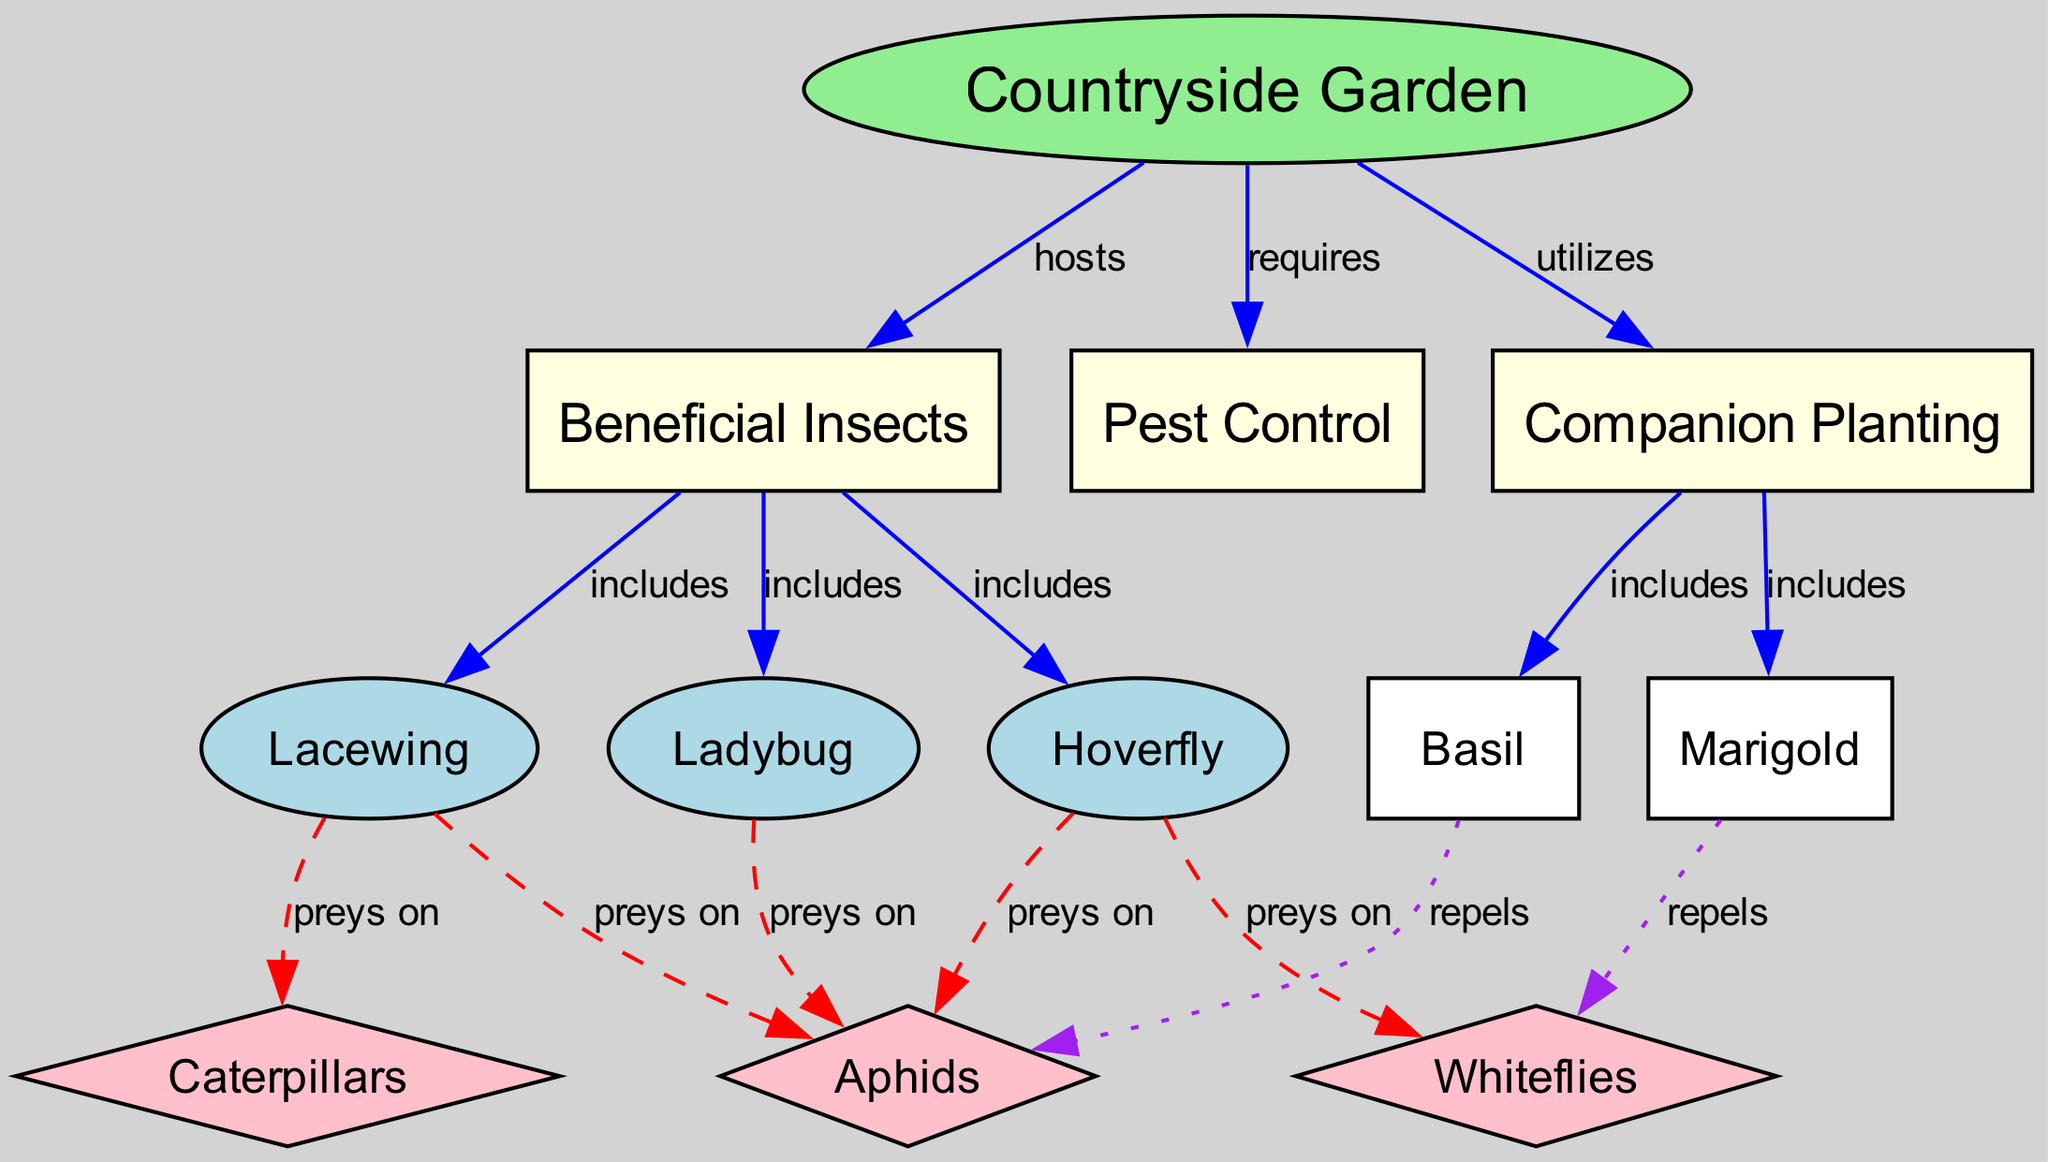What are the beneficial insects in the countryside garden? Referring to the diagram, the nodes labeled "ladybug", "lacewing", and "hoverfly" are all classified under "Beneficial Insects".
Answer: ladybug, lacewing, hoverfly How many types of pests are targeted by beneficial insects? The pests shown in the diagram that are preyed upon include "aphids", "caterpillar", and "whiteflies". Therefore, there are three types.
Answer: 3 Which plant is mentioned as repelling aphids? The diagram indicates that "basil" has a relationship that shows it repels "aphids". This is clearly noted in the edge labeled "repels".
Answer: basil What kind of pest does the ladybug prey on? The diagram specifically shows an edge labeled "preys on" between "ladybug" and "aphid", indicating that the ladybug primarily targets aphids as pests.
Answer: aphid Which beneficial insect includes the hoverfly? The diagram states that "Beneficial Insects" include "hoverfly", which is a direct label from the edge in the diagram linking these nodes.
Answer: Beneficial Insects How does companion planting benefit the countryside garden? The diagram reveals that companion planting utilizes plants like "marigold" and "basil", which in turn help with pest control by repelling harmful insects like "whitefly" and "aphid".
Answer: pest control What is the relationship between marigold and whiteflies? In the diagram, the edge shows "marigold" has a relationship labeled "repels" with "whitefly", demonstrating that marigold acts to deter whiteflies in the garden.
Answer: repels Which two pests are preyed upon by lacewing? According to the diagram, the lacewing preys on both "aphids" and "caterpillar", as indicated by the associated edges showing the prey relation.
Answer: aphids, caterpillar What does the countryside garden require for maintaining pest control? The diagram illustrates that the "Countryside Garden" requires "Pest Control", implying that it needs mechanisms or entities to manage pest populations effectively.
Answer: Pest Control 